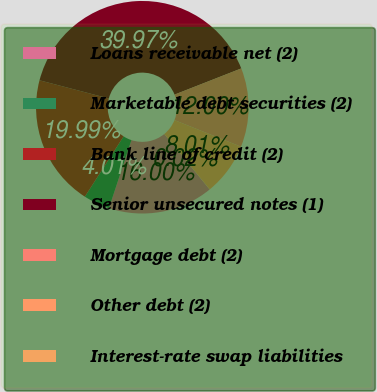<chart> <loc_0><loc_0><loc_500><loc_500><pie_chart><fcel>Loans receivable net (2)<fcel>Marketable debt securities (2)<fcel>Bank line of credit (2)<fcel>Senior unsecured notes (1)<fcel>Mortgage debt (2)<fcel>Other debt (2)<fcel>Interest-rate swap liabilities<nl><fcel>16.0%<fcel>4.01%<fcel>19.99%<fcel>39.97%<fcel>12.0%<fcel>8.01%<fcel>0.02%<nl></chart> 